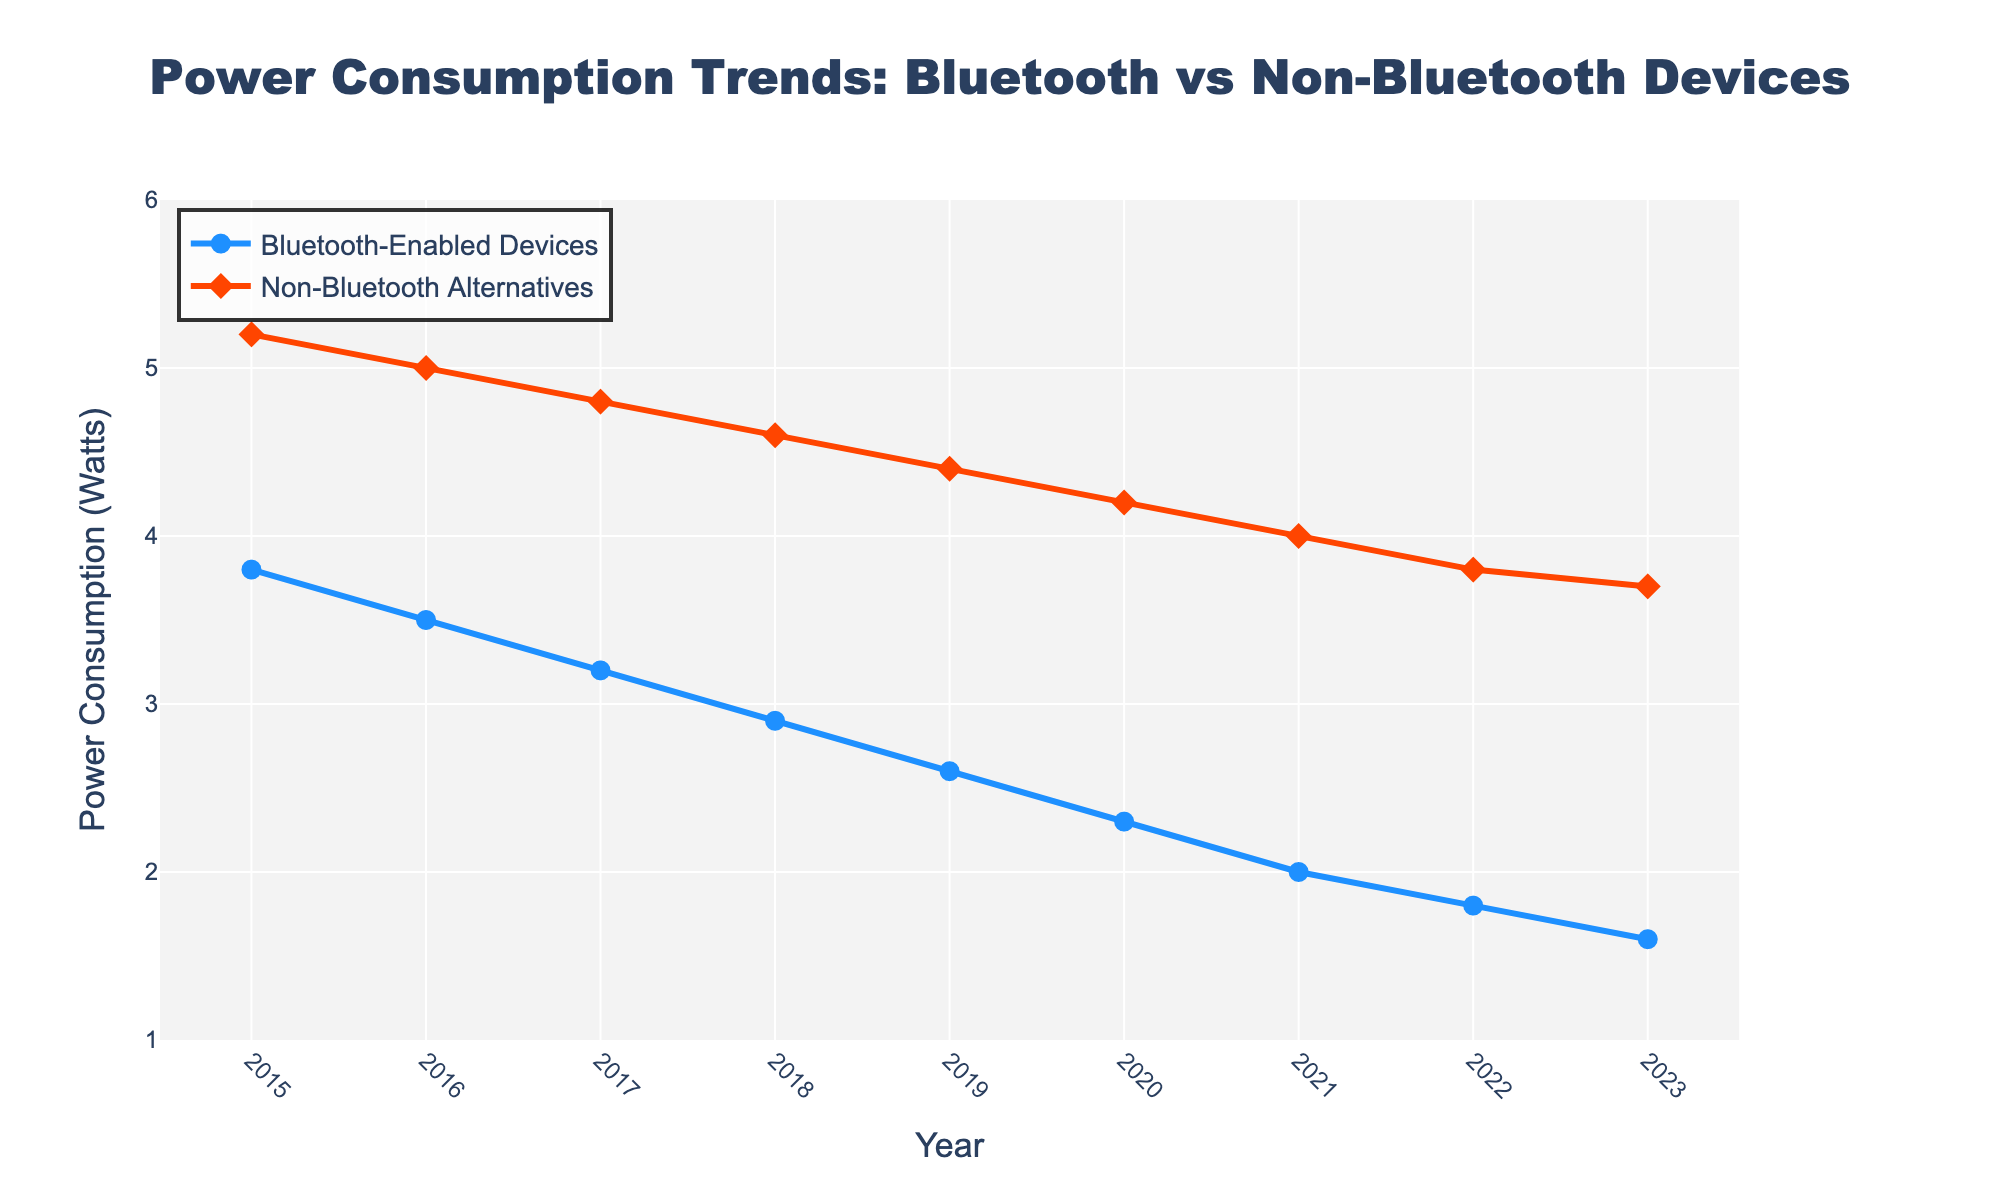What's the trend in power consumption for Bluetooth-enabled devices from 2015 to 2023? Observing the line for Bluetooth-enabled devices, there is a consistent decrease in power consumption from 3.8 Watts in 2015 to 1.6 Watts in 2023.
Answer: Decreasing trend What is the difference in power consumption between Bluetooth-enabled devices and non-Bluetooth alternatives in 2019? In 2019, the power consumption for Bluetooth-enabled devices is 2.6 Watts, while for non-Bluetooth alternatives, it is 4.4 Watts. The difference is 4.4 - 2.6 = 1.8 Watts.
Answer: 1.8 Watts Which year shows the largest gap in power consumption between Bluetooth-enabled devices and non-Bluetooth alternatives? The largest gap is in 2015, with Bluetooth-enabled devices consuming 3.8 Watts and non-Bluetooth alternatives consuming 5.2 Watts. The difference is 1.4 Watts.
Answer: 2015 By how much did the power consumption for Bluetooth-enabled devices decrease between 2015 and 2023? The power consumption in 2015 is 3.8 Watts, and in 2023 it is 1.6 Watts. The decrease is 3.8 - 1.6 = 2.2 Watts.
Answer: 2.2 Watts In which year do both types of devices show the smallest difference in power consumption, and what's that difference? The smallest difference is in 2023, with Bluetooth-enabled devices consuming 1.6 Watts and non-Bluetooth alternatives consuming 3.7 Watts. The difference is 3.7 - 1.6 = 2.1 Watts.
Answer: 2023, 2.1 Watts How many years did it take for Bluetooth-enabled devices' power consumption to drop below 2 Watts? The power consumption for Bluetooth-enabled devices dropped below 2 Watts in 2021. From 2015, it took 6 years.
Answer: 6 years Which year experienced only a 0.2 Watt decrease in power consumption for non-Bluetooth alternatives compared to the previous year? Comparing year-to-year values, between 2022 (3.8 Watts) and 2023 (3.7 Watts), the decrease is 0.2 Watts.
Answer: 2023 What's the average power consumption for Bluetooth-enabled devices over the entire period? Summing up the power consumption from 2015 to 2023: 3.8 + 3.5 + 3.2 + 2.9 + 2.6 + 2.3 + 2.0 + 1.8 + 1.6 = 23.7 Watts. Dividing by 9 (the number of years): 23.7 / 9 ≈ 2.63 Watts.
Answer: 2.63 Watts In what year did non-Bluetooth alternatives' power consumption drop below 4.5 Watts? Non-Bluetooth alternatives' power consumption dropped below 4.5 Watts in the year 2020.
Answer: 2020 